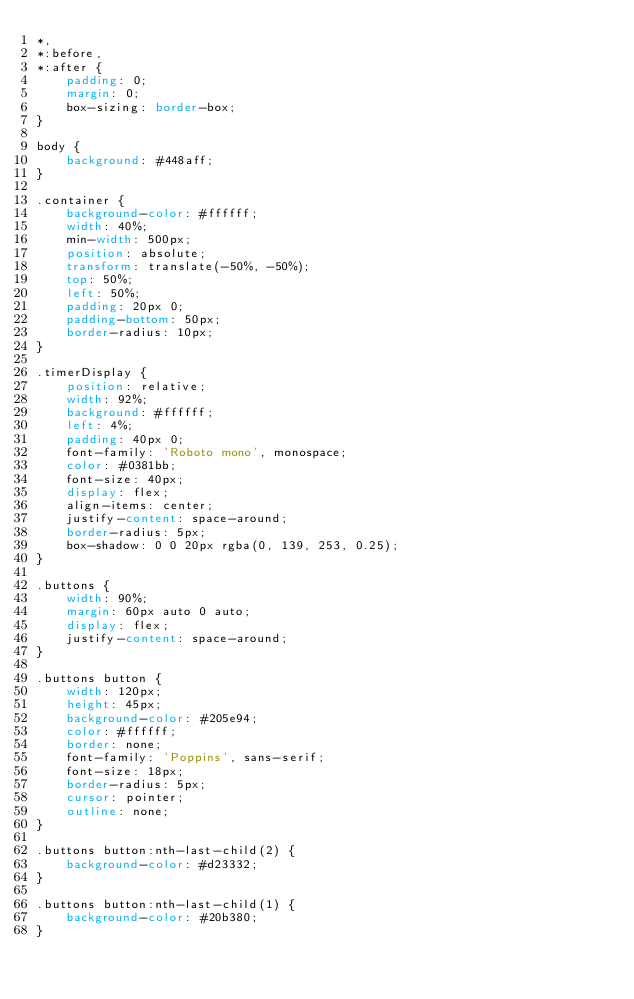Convert code to text. <code><loc_0><loc_0><loc_500><loc_500><_CSS_>*,
*:before,
*:after {
    padding: 0;
    margin: 0;
    box-sizing: border-box;
}

body {
    background: #448aff;
}

.container {
    background-color: #ffffff;
    width: 40%;
    min-width: 500px;
    position: absolute;
    transform: translate(-50%, -50%);
    top: 50%;
    left: 50%;
    padding: 20px 0;
    padding-bottom: 50px;
    border-radius: 10px;
}

.timerDisplay {
    position: relative;
    width: 92%;
    background: #ffffff;
    left: 4%;
    padding: 40px 0;
    font-family: 'Roboto mono', monospace;
    color: #0381bb;
    font-size: 40px;
    display: flex;
    align-items: center;
    justify-content: space-around;
    border-radius: 5px;
    box-shadow: 0 0 20px rgba(0, 139, 253, 0.25);
}

.buttons {
    width: 90%;
    margin: 60px auto 0 auto;
    display: flex;
    justify-content: space-around;
}

.buttons button {
    width: 120px;
    height: 45px;
    background-color: #205e94;
    color: #ffffff;
    border: none;
    font-family: 'Poppins', sans-serif;
    font-size: 18px;
    border-radius: 5px;
    cursor: pointer;
    outline: none;
}

.buttons button:nth-last-child(2) {
    background-color: #d23332;
}

.buttons button:nth-last-child(1) {
    background-color: #20b380;
}</code> 